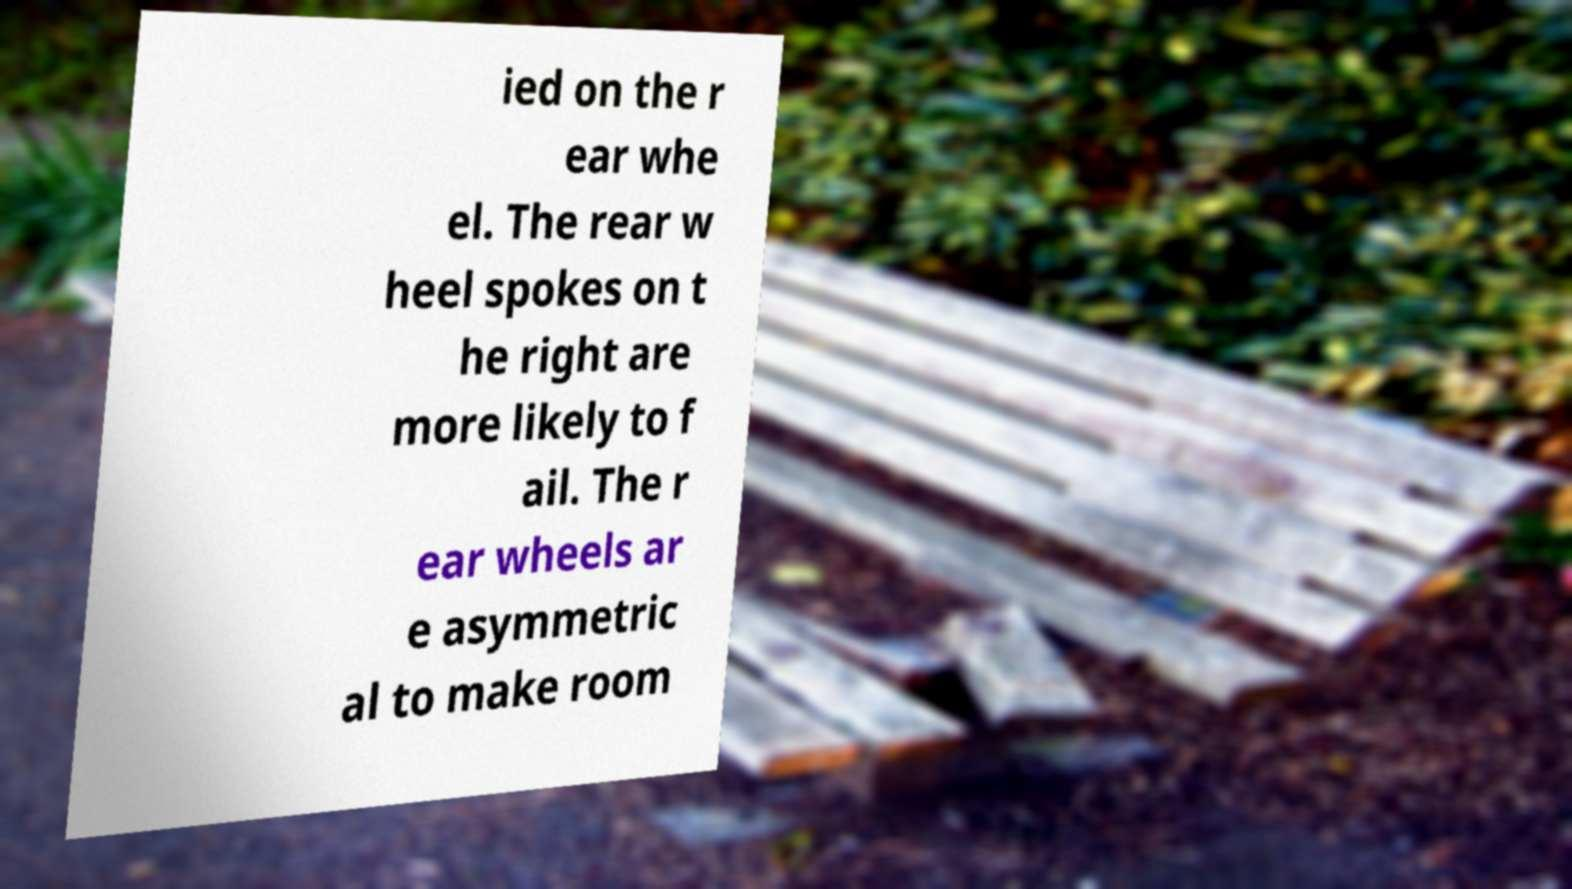Could you extract and type out the text from this image? ied on the r ear whe el. The rear w heel spokes on t he right are more likely to f ail. The r ear wheels ar e asymmetric al to make room 